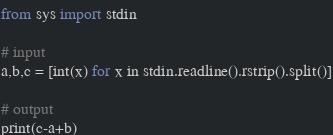Convert code to text. <code><loc_0><loc_0><loc_500><loc_500><_Python_>from sys import stdin

# input
a,b,c = [int(x) for x in stdin.readline().rstrip().split()]

# output
print(c-a+b)
</code> 